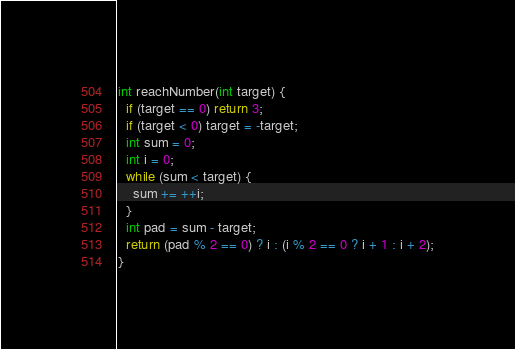<code> <loc_0><loc_0><loc_500><loc_500><_C_>
int reachNumber(int target) {
  if (target == 0) return 3;
  if (target < 0) target = -target;
  int sum = 0;
  int i = 0;
  while (sum < target) {
    sum += ++i;
  }
  int pad = sum - target;
  return (pad % 2 == 0) ? i : (i % 2 == 0 ? i + 1 : i + 2);
}
</code> 